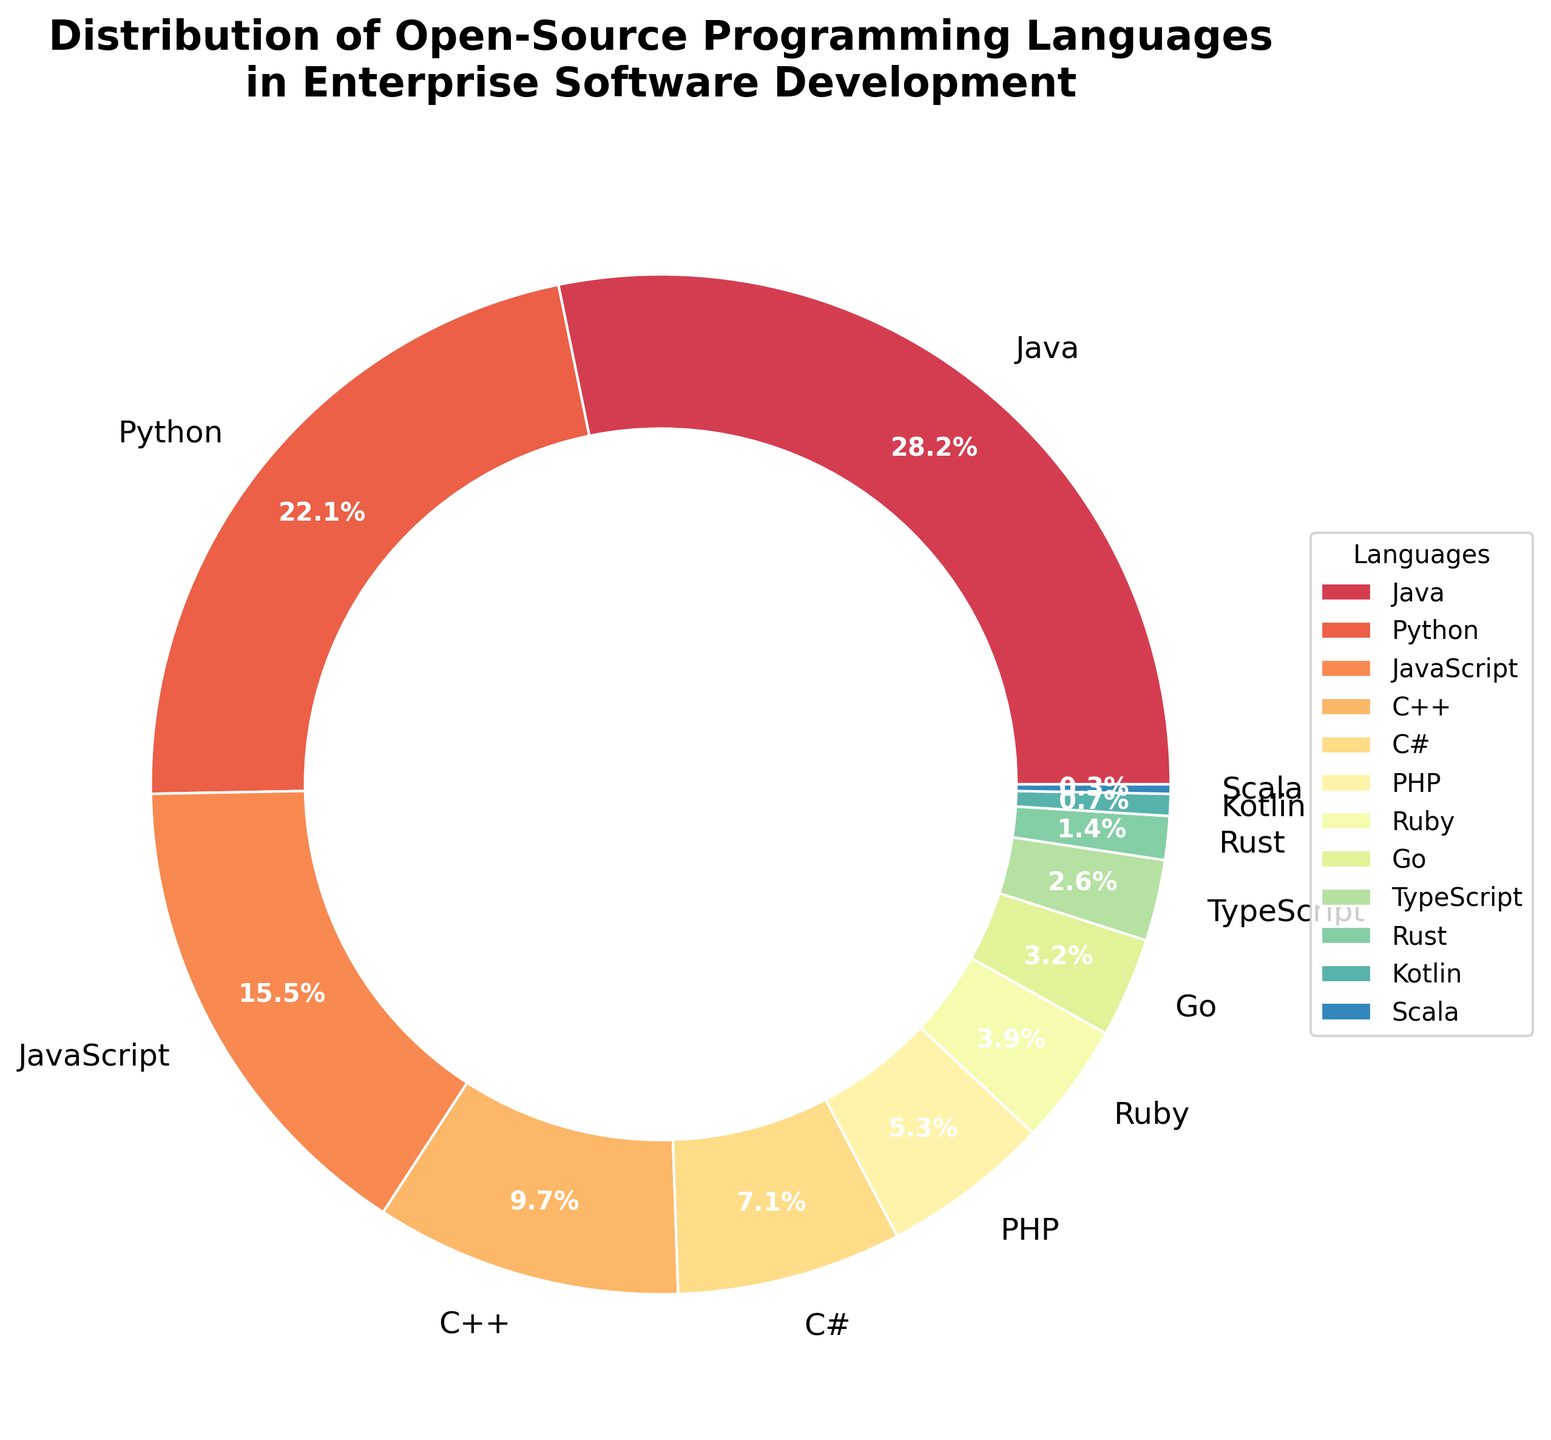Which open-source programming language has the highest percentage in enterprise software development? The slice of the pie chart with the largest percentage will indicate the language with the highest percentage. Java has a slice covering 28.5% of the chart.
Answer: Java Which two programming languages combined cover approximately half of the enterprise software development usage? Look for the two largest slices. Summing their percentages, Java (28.5%) and Python (22.3%) together account for 50.8%.
Answer: Java and Python How does the percentage of Ruby compare to C++? Find the slices labeled Ruby and C++. Ruby represents 3.9%, and C++ represents 9.8%. Ruby’s percentage is significantly lower than that of C++.
Answer: Ruby's percentage is much lower than C++ What percentage of enterprise software development is covered by languages with less than 5% share each? Add the percentages for PHP (5.4%), Ruby (3.9%), Go (3.2%), TypeScript (2.6%), Rust (1.4%), Kotlin (0.7%), and Scala (0.3%). This sum considers languages below 5%, excluding PHP. Calculating: 3.9 + 3.2 + 2.6 + 1.4 + 0.7 + 0.3 = 12.1%.
Answer: 12.1% Is Python usage in enterprise software development greater than JavaScript’s and C#’s combined? Find the percentages for Python (22.3%), JavaScript (15.7%), and C# (7.2%). Sum the percentages of JavaScript and C#: 15.7% + 7.2% = 22.9%. Python (22.3%) is slightly less than the combined value of JavaScript and C#.
Answer: No Which color represents Python in the chart, and how can it be identified? The colors are mapped in the same order as the percentages when sorted in descending order. Python has the second largest slice. By locating the second largest slice (after Java), its respective color in the Spectral colormap is identifiable, which is likely a shade of red/orange.
Answer: Likely a shade of red/orange Between TypeScript and Go, which language has a larger share and by how much? Compare the slices labeled TypeScript and Go. TypeScript accounts for 2.6%, and Go accounts for 3.2%. Subtract the percentages: 3.2% - 2.6% = 0.6%.
Answer: Go by 0.6% What is the combined percentage of Java and Rust in enterprise software development? Add the percentages of Java (28.5%) and Rust (1.4%). So, 28.5% + 1.4% = 29.9%.
Answer: 29.9% How many languages listed have a share greater than 10%? Look for slices/labels with percentages above 10%. Java (28.5%), Python (22.3%), and JavaScript (15.7%) are above 10%. Counting them, there are three such languages.
Answer: Three What's the difference in the percentage between the least used (Scala) and the most used (Java) programming languages? The least used (Scala) is 0.3%, and the most used (Java) is 28.5%. Subtracting these, 28.5% - 0.3% = 28.2%.
Answer: 28.2% 